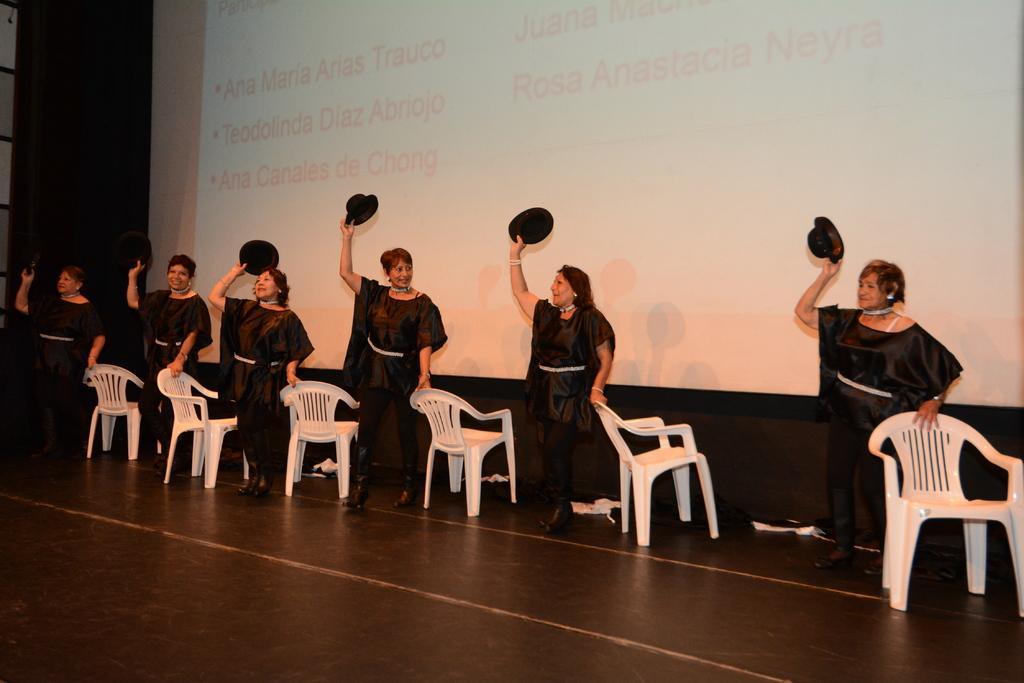Describe this image in one or two sentences. The picture is taken on the stage where there are six woman standing on the stage and wearing black dresses and hats in their hands and holding the chairs and behind them there is a big screen and write some text on it. 